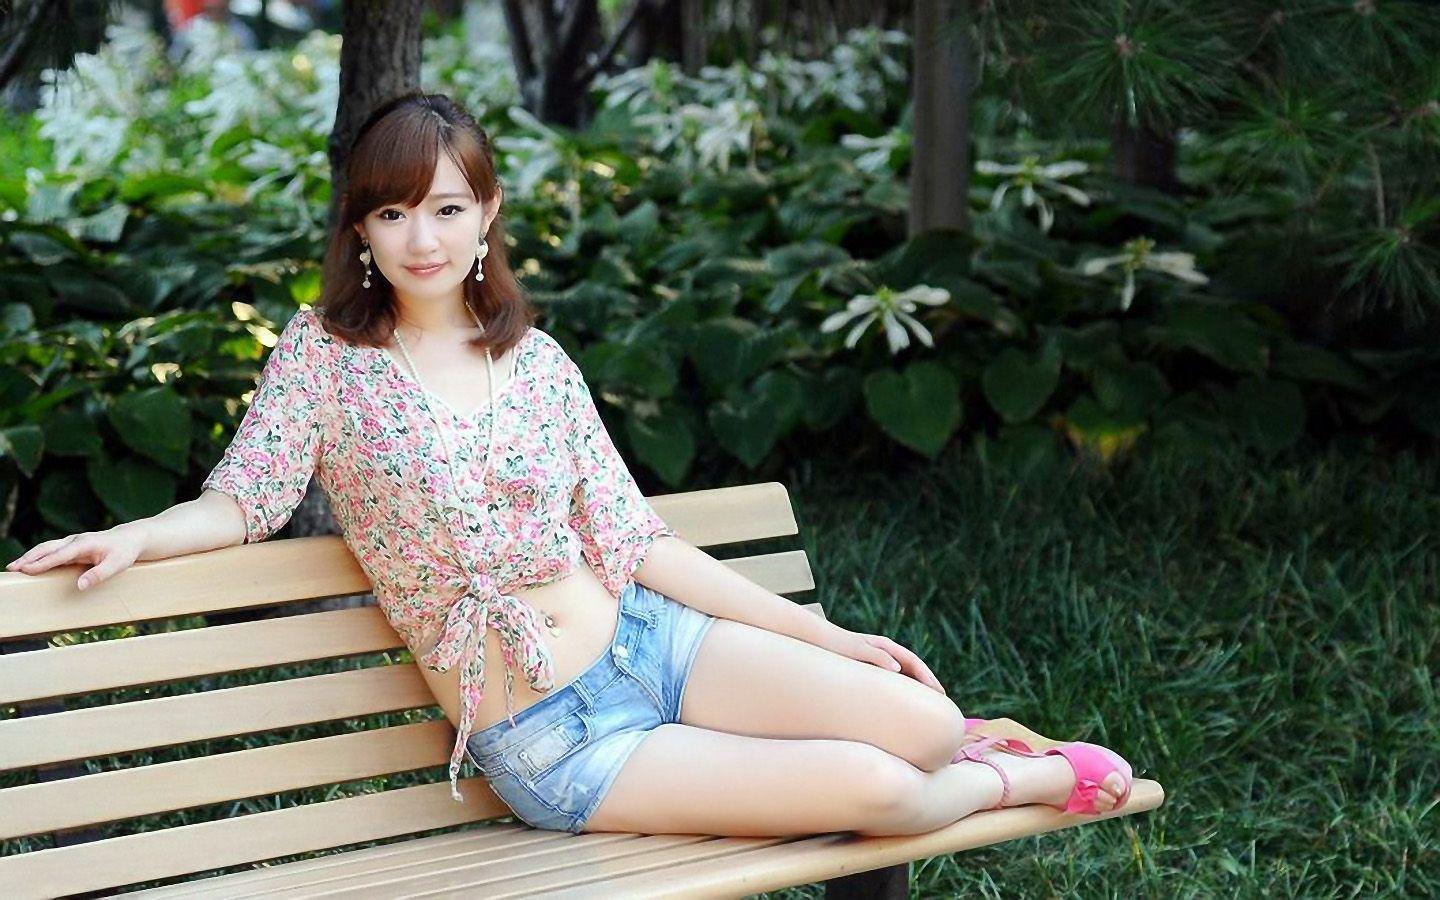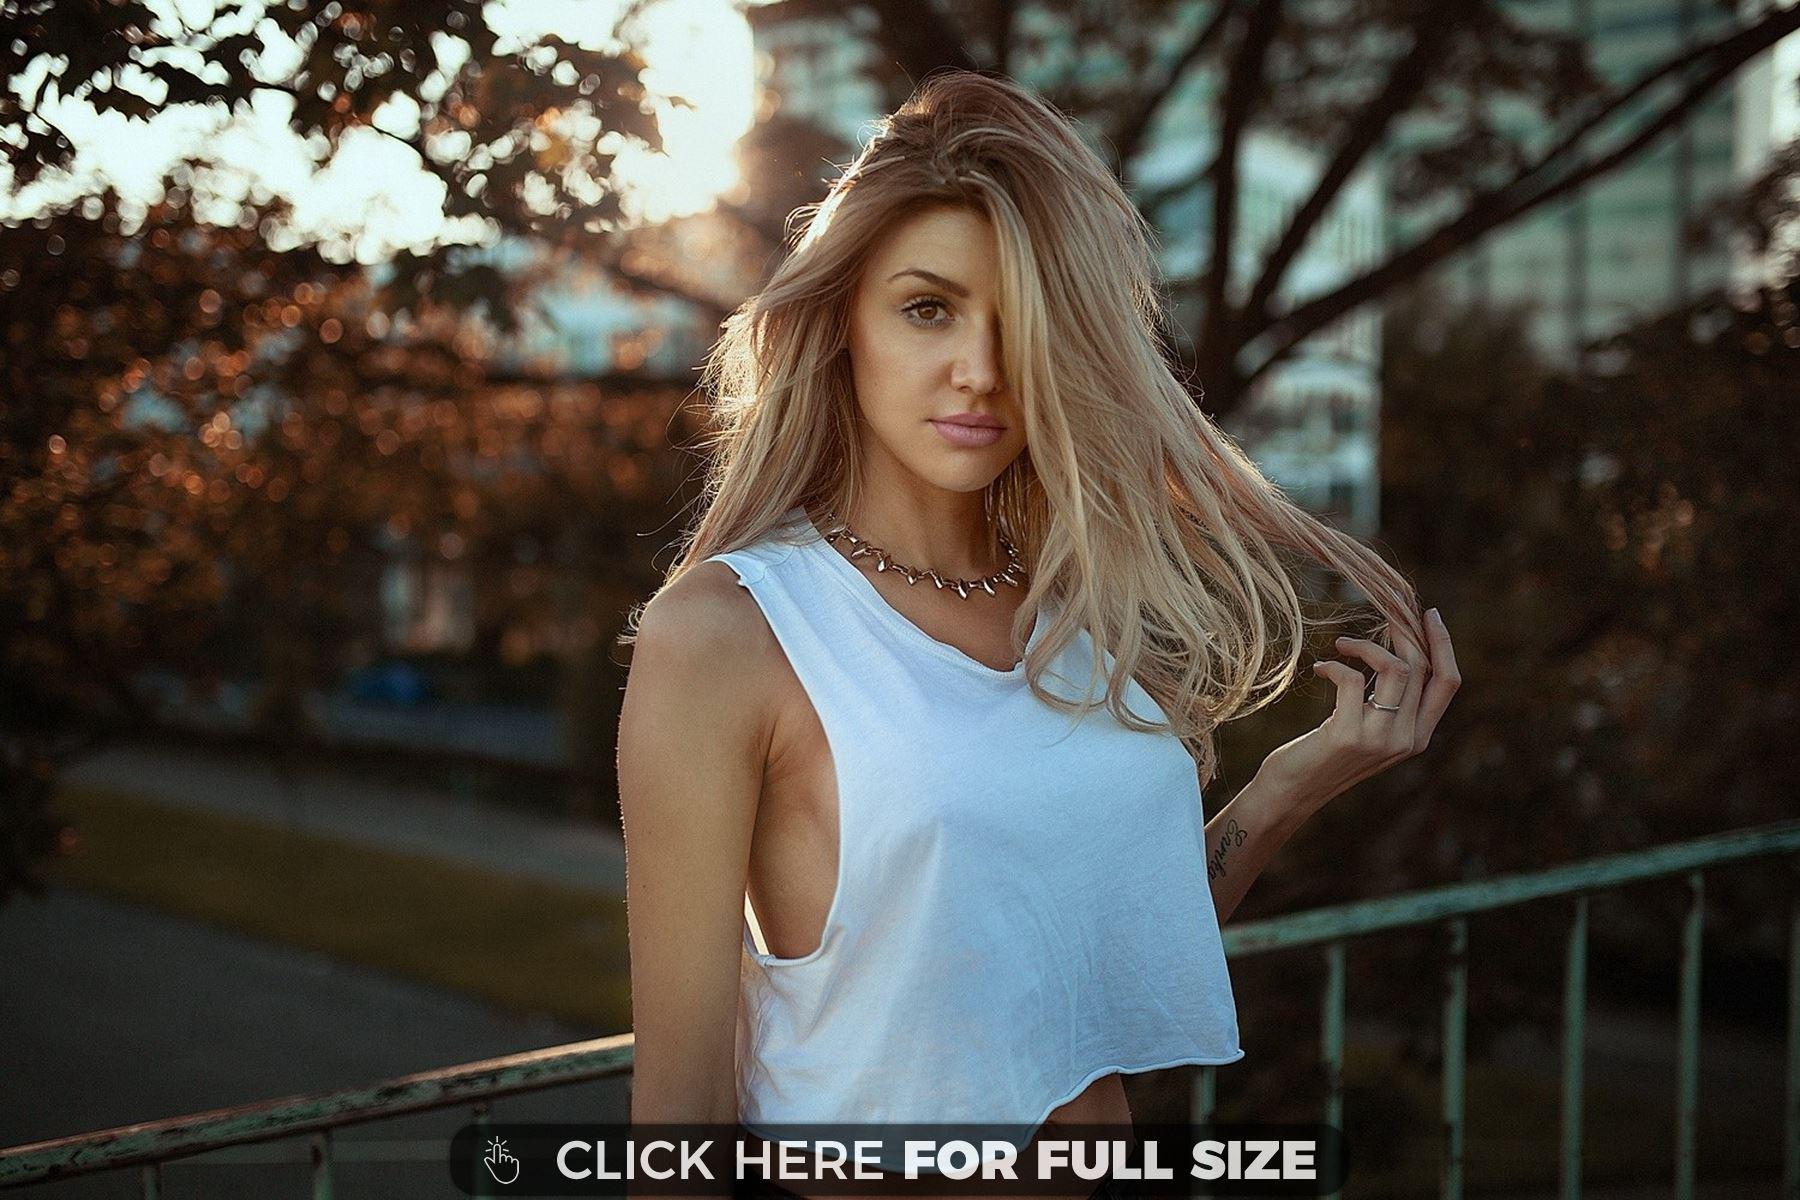The first image is the image on the left, the second image is the image on the right. Examine the images to the left and right. Is the description "One image shows exactly one girl standing and leaning with her arms on a rail, and smiling at the camera." accurate? Answer yes or no. No. 